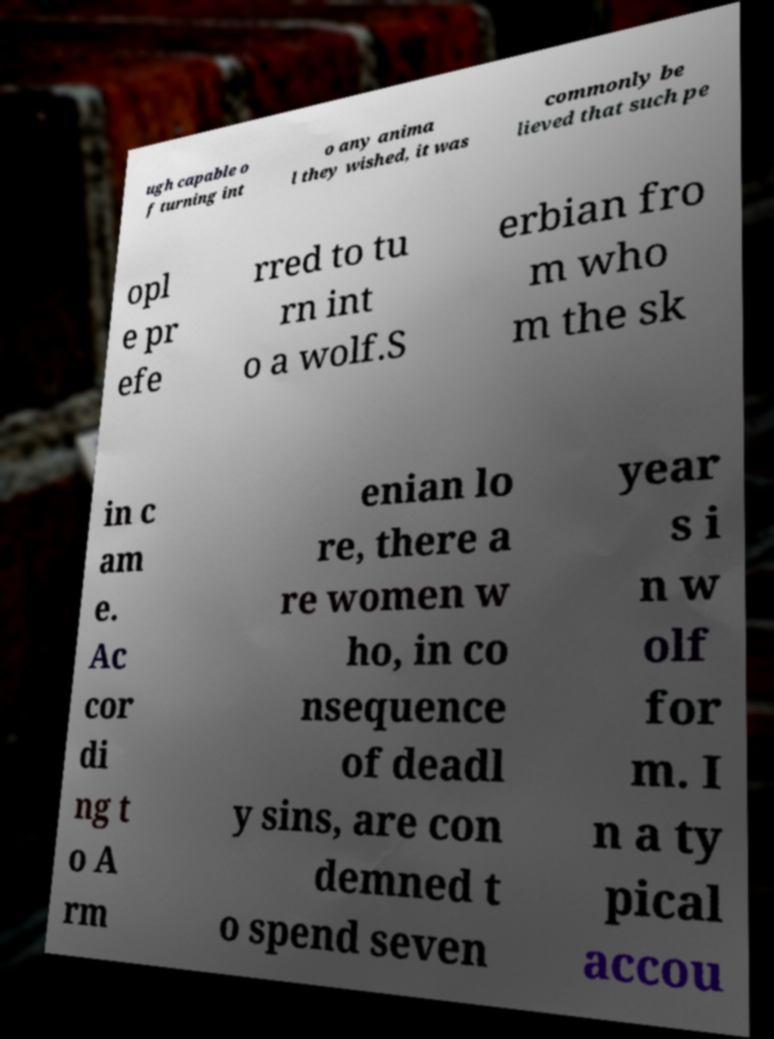Can you accurately transcribe the text from the provided image for me? ugh capable o f turning int o any anima l they wished, it was commonly be lieved that such pe opl e pr efe rred to tu rn int o a wolf.S erbian fro m who m the sk in c am e. Ac cor di ng t o A rm enian lo re, there a re women w ho, in co nsequence of deadl y sins, are con demned t o spend seven year s i n w olf for m. I n a ty pical accou 